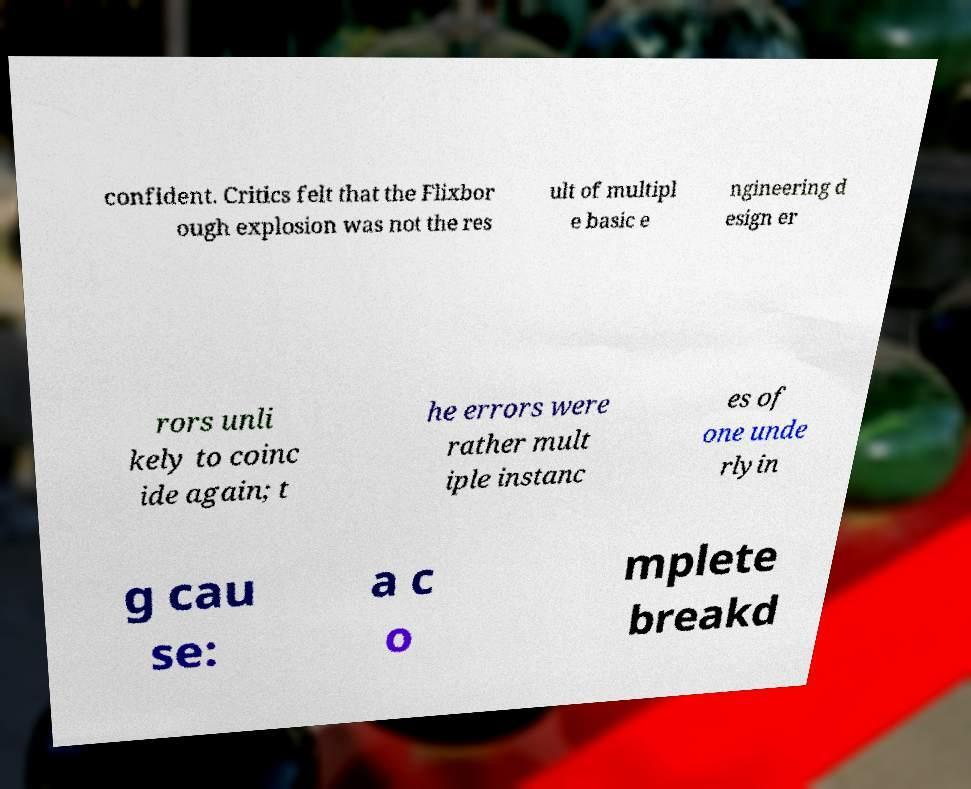Can you accurately transcribe the text from the provided image for me? confident. Critics felt that the Flixbor ough explosion was not the res ult of multipl e basic e ngineering d esign er rors unli kely to coinc ide again; t he errors were rather mult iple instanc es of one unde rlyin g cau se: a c o mplete breakd 